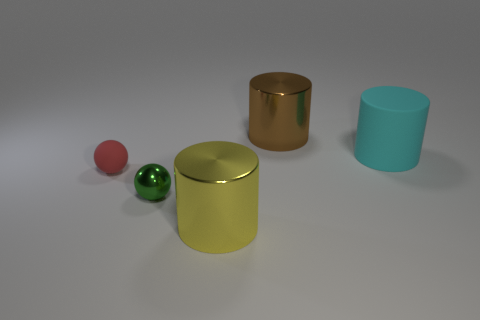Subtract all purple cylinders. Subtract all blue blocks. How many cylinders are left? 3 Add 4 large cyan things. How many objects exist? 9 Subtract all cylinders. How many objects are left? 2 Subtract all tiny green shiny cylinders. Subtract all tiny objects. How many objects are left? 3 Add 1 large yellow objects. How many large yellow objects are left? 2 Add 4 blue matte cylinders. How many blue matte cylinders exist? 4 Subtract 0 purple cylinders. How many objects are left? 5 